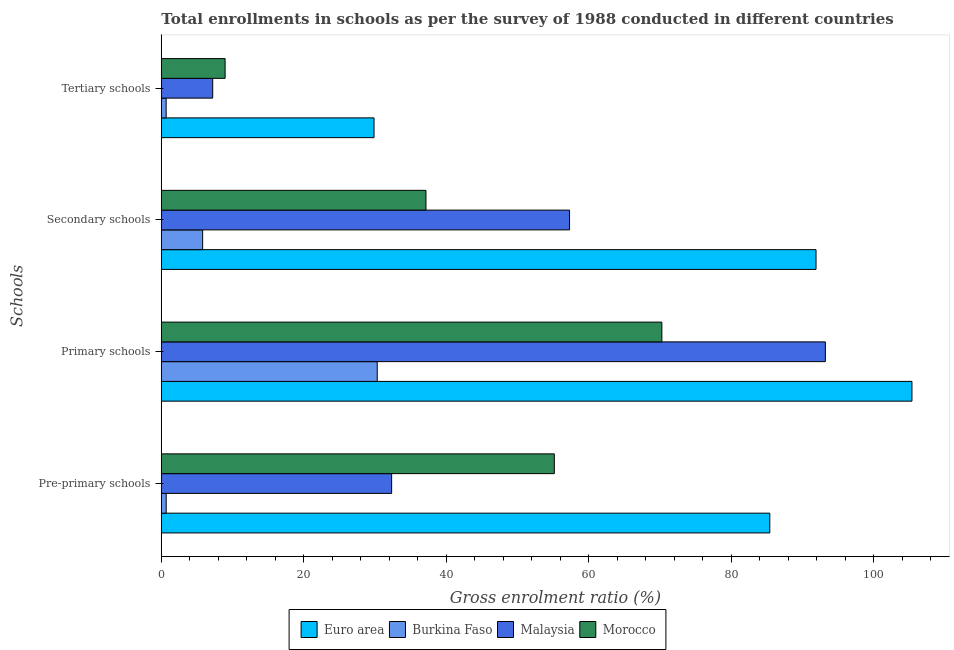How many different coloured bars are there?
Offer a very short reply. 4. How many groups of bars are there?
Your response must be concise. 4. Are the number of bars per tick equal to the number of legend labels?
Keep it short and to the point. Yes. Are the number of bars on each tick of the Y-axis equal?
Your answer should be compact. Yes. How many bars are there on the 3rd tick from the top?
Provide a short and direct response. 4. How many bars are there on the 3rd tick from the bottom?
Your answer should be very brief. 4. What is the label of the 3rd group of bars from the top?
Provide a succinct answer. Primary schools. What is the gross enrolment ratio in tertiary schools in Malaysia?
Ensure brevity in your answer.  7.22. Across all countries, what is the maximum gross enrolment ratio in primary schools?
Offer a terse response. 105.4. Across all countries, what is the minimum gross enrolment ratio in tertiary schools?
Keep it short and to the point. 0.68. In which country was the gross enrolment ratio in secondary schools maximum?
Ensure brevity in your answer.  Euro area. In which country was the gross enrolment ratio in secondary schools minimum?
Give a very brief answer. Burkina Faso. What is the total gross enrolment ratio in secondary schools in the graph?
Make the answer very short. 192.21. What is the difference between the gross enrolment ratio in tertiary schools in Burkina Faso and that in Morocco?
Offer a terse response. -8.28. What is the difference between the gross enrolment ratio in primary schools in Morocco and the gross enrolment ratio in pre-primary schools in Malaysia?
Your response must be concise. 37.94. What is the average gross enrolment ratio in pre-primary schools per country?
Ensure brevity in your answer.  43.41. What is the difference between the gross enrolment ratio in primary schools and gross enrolment ratio in pre-primary schools in Malaysia?
Offer a terse response. 60.9. In how many countries, is the gross enrolment ratio in tertiary schools greater than 92 %?
Your answer should be compact. 0. What is the ratio of the gross enrolment ratio in secondary schools in Malaysia to that in Burkina Faso?
Give a very brief answer. 9.87. Is the gross enrolment ratio in pre-primary schools in Morocco less than that in Burkina Faso?
Your response must be concise. No. Is the difference between the gross enrolment ratio in primary schools in Euro area and Burkina Faso greater than the difference between the gross enrolment ratio in secondary schools in Euro area and Burkina Faso?
Ensure brevity in your answer.  No. What is the difference between the highest and the second highest gross enrolment ratio in pre-primary schools?
Give a very brief answer. 30.25. What is the difference between the highest and the lowest gross enrolment ratio in tertiary schools?
Ensure brevity in your answer.  29.19. In how many countries, is the gross enrolment ratio in secondary schools greater than the average gross enrolment ratio in secondary schools taken over all countries?
Provide a succinct answer. 2. Is the sum of the gross enrolment ratio in tertiary schools in Malaysia and Burkina Faso greater than the maximum gross enrolment ratio in pre-primary schools across all countries?
Offer a terse response. No. Is it the case that in every country, the sum of the gross enrolment ratio in tertiary schools and gross enrolment ratio in primary schools is greater than the sum of gross enrolment ratio in secondary schools and gross enrolment ratio in pre-primary schools?
Keep it short and to the point. No. What does the 3rd bar from the top in Tertiary schools represents?
Your response must be concise. Burkina Faso. What does the 1st bar from the bottom in Primary schools represents?
Your answer should be very brief. Euro area. How many bars are there?
Make the answer very short. 16. How many countries are there in the graph?
Provide a short and direct response. 4. What is the difference between two consecutive major ticks on the X-axis?
Your response must be concise. 20. Does the graph contain grids?
Make the answer very short. No. Where does the legend appear in the graph?
Ensure brevity in your answer.  Bottom center. How many legend labels are there?
Give a very brief answer. 4. What is the title of the graph?
Offer a terse response. Total enrollments in schools as per the survey of 1988 conducted in different countries. What is the label or title of the X-axis?
Offer a terse response. Gross enrolment ratio (%). What is the label or title of the Y-axis?
Offer a very short reply. Schools. What is the Gross enrolment ratio (%) in Euro area in Pre-primary schools?
Give a very brief answer. 85.44. What is the Gross enrolment ratio (%) in Burkina Faso in Pre-primary schools?
Give a very brief answer. 0.69. What is the Gross enrolment ratio (%) of Malaysia in Pre-primary schools?
Your answer should be compact. 32.34. What is the Gross enrolment ratio (%) of Morocco in Pre-primary schools?
Ensure brevity in your answer.  55.18. What is the Gross enrolment ratio (%) in Euro area in Primary schools?
Your response must be concise. 105.4. What is the Gross enrolment ratio (%) of Burkina Faso in Primary schools?
Keep it short and to the point. 30.32. What is the Gross enrolment ratio (%) in Malaysia in Primary schools?
Provide a short and direct response. 93.24. What is the Gross enrolment ratio (%) of Morocco in Primary schools?
Offer a very short reply. 70.28. What is the Gross enrolment ratio (%) of Euro area in Secondary schools?
Your response must be concise. 91.93. What is the Gross enrolment ratio (%) of Burkina Faso in Secondary schools?
Give a very brief answer. 5.81. What is the Gross enrolment ratio (%) of Malaysia in Secondary schools?
Offer a very short reply. 57.32. What is the Gross enrolment ratio (%) in Morocco in Secondary schools?
Ensure brevity in your answer.  37.16. What is the Gross enrolment ratio (%) of Euro area in Tertiary schools?
Provide a short and direct response. 29.87. What is the Gross enrolment ratio (%) in Burkina Faso in Tertiary schools?
Keep it short and to the point. 0.68. What is the Gross enrolment ratio (%) of Malaysia in Tertiary schools?
Offer a terse response. 7.22. What is the Gross enrolment ratio (%) of Morocco in Tertiary schools?
Offer a terse response. 8.96. Across all Schools, what is the maximum Gross enrolment ratio (%) in Euro area?
Your answer should be compact. 105.4. Across all Schools, what is the maximum Gross enrolment ratio (%) in Burkina Faso?
Your answer should be very brief. 30.32. Across all Schools, what is the maximum Gross enrolment ratio (%) of Malaysia?
Give a very brief answer. 93.24. Across all Schools, what is the maximum Gross enrolment ratio (%) in Morocco?
Offer a very short reply. 70.28. Across all Schools, what is the minimum Gross enrolment ratio (%) of Euro area?
Provide a short and direct response. 29.87. Across all Schools, what is the minimum Gross enrolment ratio (%) of Burkina Faso?
Your answer should be compact. 0.68. Across all Schools, what is the minimum Gross enrolment ratio (%) of Malaysia?
Give a very brief answer. 7.22. Across all Schools, what is the minimum Gross enrolment ratio (%) in Morocco?
Ensure brevity in your answer.  8.96. What is the total Gross enrolment ratio (%) in Euro area in the graph?
Make the answer very short. 312.63. What is the total Gross enrolment ratio (%) in Burkina Faso in the graph?
Keep it short and to the point. 37.49. What is the total Gross enrolment ratio (%) of Malaysia in the graph?
Your answer should be compact. 190.11. What is the total Gross enrolment ratio (%) in Morocco in the graph?
Offer a very short reply. 171.58. What is the difference between the Gross enrolment ratio (%) of Euro area in Pre-primary schools and that in Primary schools?
Your answer should be compact. -19.96. What is the difference between the Gross enrolment ratio (%) in Burkina Faso in Pre-primary schools and that in Primary schools?
Your answer should be very brief. -29.63. What is the difference between the Gross enrolment ratio (%) in Malaysia in Pre-primary schools and that in Primary schools?
Your answer should be compact. -60.9. What is the difference between the Gross enrolment ratio (%) of Morocco in Pre-primary schools and that in Primary schools?
Offer a very short reply. -15.1. What is the difference between the Gross enrolment ratio (%) in Euro area in Pre-primary schools and that in Secondary schools?
Your response must be concise. -6.49. What is the difference between the Gross enrolment ratio (%) of Burkina Faso in Pre-primary schools and that in Secondary schools?
Ensure brevity in your answer.  -5.12. What is the difference between the Gross enrolment ratio (%) of Malaysia in Pre-primary schools and that in Secondary schools?
Provide a succinct answer. -24.98. What is the difference between the Gross enrolment ratio (%) of Morocco in Pre-primary schools and that in Secondary schools?
Offer a terse response. 18.02. What is the difference between the Gross enrolment ratio (%) in Euro area in Pre-primary schools and that in Tertiary schools?
Your response must be concise. 55.57. What is the difference between the Gross enrolment ratio (%) in Burkina Faso in Pre-primary schools and that in Tertiary schools?
Provide a succinct answer. 0.01. What is the difference between the Gross enrolment ratio (%) in Malaysia in Pre-primary schools and that in Tertiary schools?
Provide a succinct answer. 25.12. What is the difference between the Gross enrolment ratio (%) in Morocco in Pre-primary schools and that in Tertiary schools?
Keep it short and to the point. 46.22. What is the difference between the Gross enrolment ratio (%) in Euro area in Primary schools and that in Secondary schools?
Your answer should be compact. 13.47. What is the difference between the Gross enrolment ratio (%) of Burkina Faso in Primary schools and that in Secondary schools?
Your answer should be compact. 24.51. What is the difference between the Gross enrolment ratio (%) of Malaysia in Primary schools and that in Secondary schools?
Provide a short and direct response. 35.92. What is the difference between the Gross enrolment ratio (%) of Morocco in Primary schools and that in Secondary schools?
Keep it short and to the point. 33.12. What is the difference between the Gross enrolment ratio (%) of Euro area in Primary schools and that in Tertiary schools?
Make the answer very short. 75.53. What is the difference between the Gross enrolment ratio (%) in Burkina Faso in Primary schools and that in Tertiary schools?
Your response must be concise. 29.64. What is the difference between the Gross enrolment ratio (%) of Malaysia in Primary schools and that in Tertiary schools?
Ensure brevity in your answer.  86.03. What is the difference between the Gross enrolment ratio (%) in Morocco in Primary schools and that in Tertiary schools?
Offer a terse response. 61.32. What is the difference between the Gross enrolment ratio (%) of Euro area in Secondary schools and that in Tertiary schools?
Offer a very short reply. 62.06. What is the difference between the Gross enrolment ratio (%) in Burkina Faso in Secondary schools and that in Tertiary schools?
Ensure brevity in your answer.  5.13. What is the difference between the Gross enrolment ratio (%) of Malaysia in Secondary schools and that in Tertiary schools?
Make the answer very short. 50.1. What is the difference between the Gross enrolment ratio (%) of Morocco in Secondary schools and that in Tertiary schools?
Give a very brief answer. 28.2. What is the difference between the Gross enrolment ratio (%) of Euro area in Pre-primary schools and the Gross enrolment ratio (%) of Burkina Faso in Primary schools?
Provide a short and direct response. 55.12. What is the difference between the Gross enrolment ratio (%) in Euro area in Pre-primary schools and the Gross enrolment ratio (%) in Malaysia in Primary schools?
Ensure brevity in your answer.  -7.8. What is the difference between the Gross enrolment ratio (%) in Euro area in Pre-primary schools and the Gross enrolment ratio (%) in Morocco in Primary schools?
Offer a very short reply. 15.16. What is the difference between the Gross enrolment ratio (%) of Burkina Faso in Pre-primary schools and the Gross enrolment ratio (%) of Malaysia in Primary schools?
Your response must be concise. -92.55. What is the difference between the Gross enrolment ratio (%) in Burkina Faso in Pre-primary schools and the Gross enrolment ratio (%) in Morocco in Primary schools?
Provide a short and direct response. -69.59. What is the difference between the Gross enrolment ratio (%) in Malaysia in Pre-primary schools and the Gross enrolment ratio (%) in Morocco in Primary schools?
Ensure brevity in your answer.  -37.94. What is the difference between the Gross enrolment ratio (%) in Euro area in Pre-primary schools and the Gross enrolment ratio (%) in Burkina Faso in Secondary schools?
Your answer should be very brief. 79.63. What is the difference between the Gross enrolment ratio (%) of Euro area in Pre-primary schools and the Gross enrolment ratio (%) of Malaysia in Secondary schools?
Offer a very short reply. 28.12. What is the difference between the Gross enrolment ratio (%) in Euro area in Pre-primary schools and the Gross enrolment ratio (%) in Morocco in Secondary schools?
Your answer should be very brief. 48.28. What is the difference between the Gross enrolment ratio (%) in Burkina Faso in Pre-primary schools and the Gross enrolment ratio (%) in Malaysia in Secondary schools?
Give a very brief answer. -56.63. What is the difference between the Gross enrolment ratio (%) of Burkina Faso in Pre-primary schools and the Gross enrolment ratio (%) of Morocco in Secondary schools?
Offer a very short reply. -36.47. What is the difference between the Gross enrolment ratio (%) in Malaysia in Pre-primary schools and the Gross enrolment ratio (%) in Morocco in Secondary schools?
Offer a very short reply. -4.82. What is the difference between the Gross enrolment ratio (%) of Euro area in Pre-primary schools and the Gross enrolment ratio (%) of Burkina Faso in Tertiary schools?
Provide a short and direct response. 84.76. What is the difference between the Gross enrolment ratio (%) of Euro area in Pre-primary schools and the Gross enrolment ratio (%) of Malaysia in Tertiary schools?
Provide a succinct answer. 78.22. What is the difference between the Gross enrolment ratio (%) of Euro area in Pre-primary schools and the Gross enrolment ratio (%) of Morocco in Tertiary schools?
Ensure brevity in your answer.  76.48. What is the difference between the Gross enrolment ratio (%) of Burkina Faso in Pre-primary schools and the Gross enrolment ratio (%) of Malaysia in Tertiary schools?
Your answer should be very brief. -6.53. What is the difference between the Gross enrolment ratio (%) in Burkina Faso in Pre-primary schools and the Gross enrolment ratio (%) in Morocco in Tertiary schools?
Offer a terse response. -8.27. What is the difference between the Gross enrolment ratio (%) of Malaysia in Pre-primary schools and the Gross enrolment ratio (%) of Morocco in Tertiary schools?
Offer a terse response. 23.38. What is the difference between the Gross enrolment ratio (%) of Euro area in Primary schools and the Gross enrolment ratio (%) of Burkina Faso in Secondary schools?
Offer a very short reply. 99.59. What is the difference between the Gross enrolment ratio (%) of Euro area in Primary schools and the Gross enrolment ratio (%) of Malaysia in Secondary schools?
Make the answer very short. 48.08. What is the difference between the Gross enrolment ratio (%) in Euro area in Primary schools and the Gross enrolment ratio (%) in Morocco in Secondary schools?
Your answer should be compact. 68.24. What is the difference between the Gross enrolment ratio (%) of Burkina Faso in Primary schools and the Gross enrolment ratio (%) of Malaysia in Secondary schools?
Offer a very short reply. -27. What is the difference between the Gross enrolment ratio (%) of Burkina Faso in Primary schools and the Gross enrolment ratio (%) of Morocco in Secondary schools?
Ensure brevity in your answer.  -6.84. What is the difference between the Gross enrolment ratio (%) of Malaysia in Primary schools and the Gross enrolment ratio (%) of Morocco in Secondary schools?
Provide a short and direct response. 56.08. What is the difference between the Gross enrolment ratio (%) in Euro area in Primary schools and the Gross enrolment ratio (%) in Burkina Faso in Tertiary schools?
Ensure brevity in your answer.  104.72. What is the difference between the Gross enrolment ratio (%) of Euro area in Primary schools and the Gross enrolment ratio (%) of Malaysia in Tertiary schools?
Make the answer very short. 98.18. What is the difference between the Gross enrolment ratio (%) in Euro area in Primary schools and the Gross enrolment ratio (%) in Morocco in Tertiary schools?
Your response must be concise. 96.44. What is the difference between the Gross enrolment ratio (%) of Burkina Faso in Primary schools and the Gross enrolment ratio (%) of Malaysia in Tertiary schools?
Keep it short and to the point. 23.1. What is the difference between the Gross enrolment ratio (%) in Burkina Faso in Primary schools and the Gross enrolment ratio (%) in Morocco in Tertiary schools?
Your answer should be very brief. 21.36. What is the difference between the Gross enrolment ratio (%) of Malaysia in Primary schools and the Gross enrolment ratio (%) of Morocco in Tertiary schools?
Your answer should be very brief. 84.28. What is the difference between the Gross enrolment ratio (%) of Euro area in Secondary schools and the Gross enrolment ratio (%) of Burkina Faso in Tertiary schools?
Make the answer very short. 91.25. What is the difference between the Gross enrolment ratio (%) in Euro area in Secondary schools and the Gross enrolment ratio (%) in Malaysia in Tertiary schools?
Provide a short and direct response. 84.71. What is the difference between the Gross enrolment ratio (%) in Euro area in Secondary schools and the Gross enrolment ratio (%) in Morocco in Tertiary schools?
Provide a succinct answer. 82.97. What is the difference between the Gross enrolment ratio (%) of Burkina Faso in Secondary schools and the Gross enrolment ratio (%) of Malaysia in Tertiary schools?
Provide a short and direct response. -1.41. What is the difference between the Gross enrolment ratio (%) in Burkina Faso in Secondary schools and the Gross enrolment ratio (%) in Morocco in Tertiary schools?
Ensure brevity in your answer.  -3.15. What is the difference between the Gross enrolment ratio (%) in Malaysia in Secondary schools and the Gross enrolment ratio (%) in Morocco in Tertiary schools?
Offer a very short reply. 48.36. What is the average Gross enrolment ratio (%) of Euro area per Schools?
Offer a very short reply. 78.16. What is the average Gross enrolment ratio (%) of Burkina Faso per Schools?
Give a very brief answer. 9.37. What is the average Gross enrolment ratio (%) of Malaysia per Schools?
Make the answer very short. 47.53. What is the average Gross enrolment ratio (%) of Morocco per Schools?
Provide a short and direct response. 42.89. What is the difference between the Gross enrolment ratio (%) of Euro area and Gross enrolment ratio (%) of Burkina Faso in Pre-primary schools?
Provide a short and direct response. 84.75. What is the difference between the Gross enrolment ratio (%) of Euro area and Gross enrolment ratio (%) of Malaysia in Pre-primary schools?
Ensure brevity in your answer.  53.1. What is the difference between the Gross enrolment ratio (%) of Euro area and Gross enrolment ratio (%) of Morocco in Pre-primary schools?
Give a very brief answer. 30.25. What is the difference between the Gross enrolment ratio (%) in Burkina Faso and Gross enrolment ratio (%) in Malaysia in Pre-primary schools?
Your answer should be very brief. -31.65. What is the difference between the Gross enrolment ratio (%) of Burkina Faso and Gross enrolment ratio (%) of Morocco in Pre-primary schools?
Your response must be concise. -54.5. What is the difference between the Gross enrolment ratio (%) in Malaysia and Gross enrolment ratio (%) in Morocco in Pre-primary schools?
Offer a very short reply. -22.84. What is the difference between the Gross enrolment ratio (%) of Euro area and Gross enrolment ratio (%) of Burkina Faso in Primary schools?
Make the answer very short. 75.08. What is the difference between the Gross enrolment ratio (%) of Euro area and Gross enrolment ratio (%) of Malaysia in Primary schools?
Your answer should be very brief. 12.16. What is the difference between the Gross enrolment ratio (%) in Euro area and Gross enrolment ratio (%) in Morocco in Primary schools?
Your answer should be very brief. 35.12. What is the difference between the Gross enrolment ratio (%) of Burkina Faso and Gross enrolment ratio (%) of Malaysia in Primary schools?
Keep it short and to the point. -62.92. What is the difference between the Gross enrolment ratio (%) of Burkina Faso and Gross enrolment ratio (%) of Morocco in Primary schools?
Your answer should be compact. -39.96. What is the difference between the Gross enrolment ratio (%) of Malaysia and Gross enrolment ratio (%) of Morocco in Primary schools?
Offer a terse response. 22.96. What is the difference between the Gross enrolment ratio (%) of Euro area and Gross enrolment ratio (%) of Burkina Faso in Secondary schools?
Your answer should be compact. 86.12. What is the difference between the Gross enrolment ratio (%) in Euro area and Gross enrolment ratio (%) in Malaysia in Secondary schools?
Your response must be concise. 34.61. What is the difference between the Gross enrolment ratio (%) in Euro area and Gross enrolment ratio (%) in Morocco in Secondary schools?
Your answer should be compact. 54.77. What is the difference between the Gross enrolment ratio (%) in Burkina Faso and Gross enrolment ratio (%) in Malaysia in Secondary schools?
Provide a short and direct response. -51.51. What is the difference between the Gross enrolment ratio (%) of Burkina Faso and Gross enrolment ratio (%) of Morocco in Secondary schools?
Make the answer very short. -31.35. What is the difference between the Gross enrolment ratio (%) of Malaysia and Gross enrolment ratio (%) of Morocco in Secondary schools?
Your response must be concise. 20.16. What is the difference between the Gross enrolment ratio (%) of Euro area and Gross enrolment ratio (%) of Burkina Faso in Tertiary schools?
Ensure brevity in your answer.  29.19. What is the difference between the Gross enrolment ratio (%) in Euro area and Gross enrolment ratio (%) in Malaysia in Tertiary schools?
Ensure brevity in your answer.  22.65. What is the difference between the Gross enrolment ratio (%) in Euro area and Gross enrolment ratio (%) in Morocco in Tertiary schools?
Your answer should be very brief. 20.91. What is the difference between the Gross enrolment ratio (%) of Burkina Faso and Gross enrolment ratio (%) of Malaysia in Tertiary schools?
Provide a short and direct response. -6.54. What is the difference between the Gross enrolment ratio (%) of Burkina Faso and Gross enrolment ratio (%) of Morocco in Tertiary schools?
Ensure brevity in your answer.  -8.28. What is the difference between the Gross enrolment ratio (%) of Malaysia and Gross enrolment ratio (%) of Morocco in Tertiary schools?
Provide a succinct answer. -1.74. What is the ratio of the Gross enrolment ratio (%) of Euro area in Pre-primary schools to that in Primary schools?
Make the answer very short. 0.81. What is the ratio of the Gross enrolment ratio (%) in Burkina Faso in Pre-primary schools to that in Primary schools?
Ensure brevity in your answer.  0.02. What is the ratio of the Gross enrolment ratio (%) in Malaysia in Pre-primary schools to that in Primary schools?
Offer a terse response. 0.35. What is the ratio of the Gross enrolment ratio (%) in Morocco in Pre-primary schools to that in Primary schools?
Offer a terse response. 0.79. What is the ratio of the Gross enrolment ratio (%) of Euro area in Pre-primary schools to that in Secondary schools?
Offer a very short reply. 0.93. What is the ratio of the Gross enrolment ratio (%) of Burkina Faso in Pre-primary schools to that in Secondary schools?
Provide a succinct answer. 0.12. What is the ratio of the Gross enrolment ratio (%) in Malaysia in Pre-primary schools to that in Secondary schools?
Offer a terse response. 0.56. What is the ratio of the Gross enrolment ratio (%) of Morocco in Pre-primary schools to that in Secondary schools?
Your response must be concise. 1.49. What is the ratio of the Gross enrolment ratio (%) of Euro area in Pre-primary schools to that in Tertiary schools?
Your answer should be very brief. 2.86. What is the ratio of the Gross enrolment ratio (%) of Burkina Faso in Pre-primary schools to that in Tertiary schools?
Provide a succinct answer. 1.01. What is the ratio of the Gross enrolment ratio (%) in Malaysia in Pre-primary schools to that in Tertiary schools?
Offer a very short reply. 4.48. What is the ratio of the Gross enrolment ratio (%) of Morocco in Pre-primary schools to that in Tertiary schools?
Offer a very short reply. 6.16. What is the ratio of the Gross enrolment ratio (%) in Euro area in Primary schools to that in Secondary schools?
Keep it short and to the point. 1.15. What is the ratio of the Gross enrolment ratio (%) of Burkina Faso in Primary schools to that in Secondary schools?
Provide a short and direct response. 5.22. What is the ratio of the Gross enrolment ratio (%) of Malaysia in Primary schools to that in Secondary schools?
Give a very brief answer. 1.63. What is the ratio of the Gross enrolment ratio (%) of Morocco in Primary schools to that in Secondary schools?
Provide a succinct answer. 1.89. What is the ratio of the Gross enrolment ratio (%) in Euro area in Primary schools to that in Tertiary schools?
Your answer should be compact. 3.53. What is the ratio of the Gross enrolment ratio (%) in Burkina Faso in Primary schools to that in Tertiary schools?
Offer a terse response. 44.68. What is the ratio of the Gross enrolment ratio (%) of Malaysia in Primary schools to that in Tertiary schools?
Your answer should be compact. 12.92. What is the ratio of the Gross enrolment ratio (%) in Morocco in Primary schools to that in Tertiary schools?
Your answer should be very brief. 7.85. What is the ratio of the Gross enrolment ratio (%) of Euro area in Secondary schools to that in Tertiary schools?
Your response must be concise. 3.08. What is the ratio of the Gross enrolment ratio (%) of Burkina Faso in Secondary schools to that in Tertiary schools?
Ensure brevity in your answer.  8.55. What is the ratio of the Gross enrolment ratio (%) of Malaysia in Secondary schools to that in Tertiary schools?
Offer a very short reply. 7.94. What is the ratio of the Gross enrolment ratio (%) of Morocco in Secondary schools to that in Tertiary schools?
Provide a short and direct response. 4.15. What is the difference between the highest and the second highest Gross enrolment ratio (%) in Euro area?
Your answer should be very brief. 13.47. What is the difference between the highest and the second highest Gross enrolment ratio (%) of Burkina Faso?
Provide a short and direct response. 24.51. What is the difference between the highest and the second highest Gross enrolment ratio (%) of Malaysia?
Provide a succinct answer. 35.92. What is the difference between the highest and the second highest Gross enrolment ratio (%) in Morocco?
Keep it short and to the point. 15.1. What is the difference between the highest and the lowest Gross enrolment ratio (%) of Euro area?
Your response must be concise. 75.53. What is the difference between the highest and the lowest Gross enrolment ratio (%) in Burkina Faso?
Keep it short and to the point. 29.64. What is the difference between the highest and the lowest Gross enrolment ratio (%) in Malaysia?
Provide a short and direct response. 86.03. What is the difference between the highest and the lowest Gross enrolment ratio (%) in Morocco?
Provide a short and direct response. 61.32. 